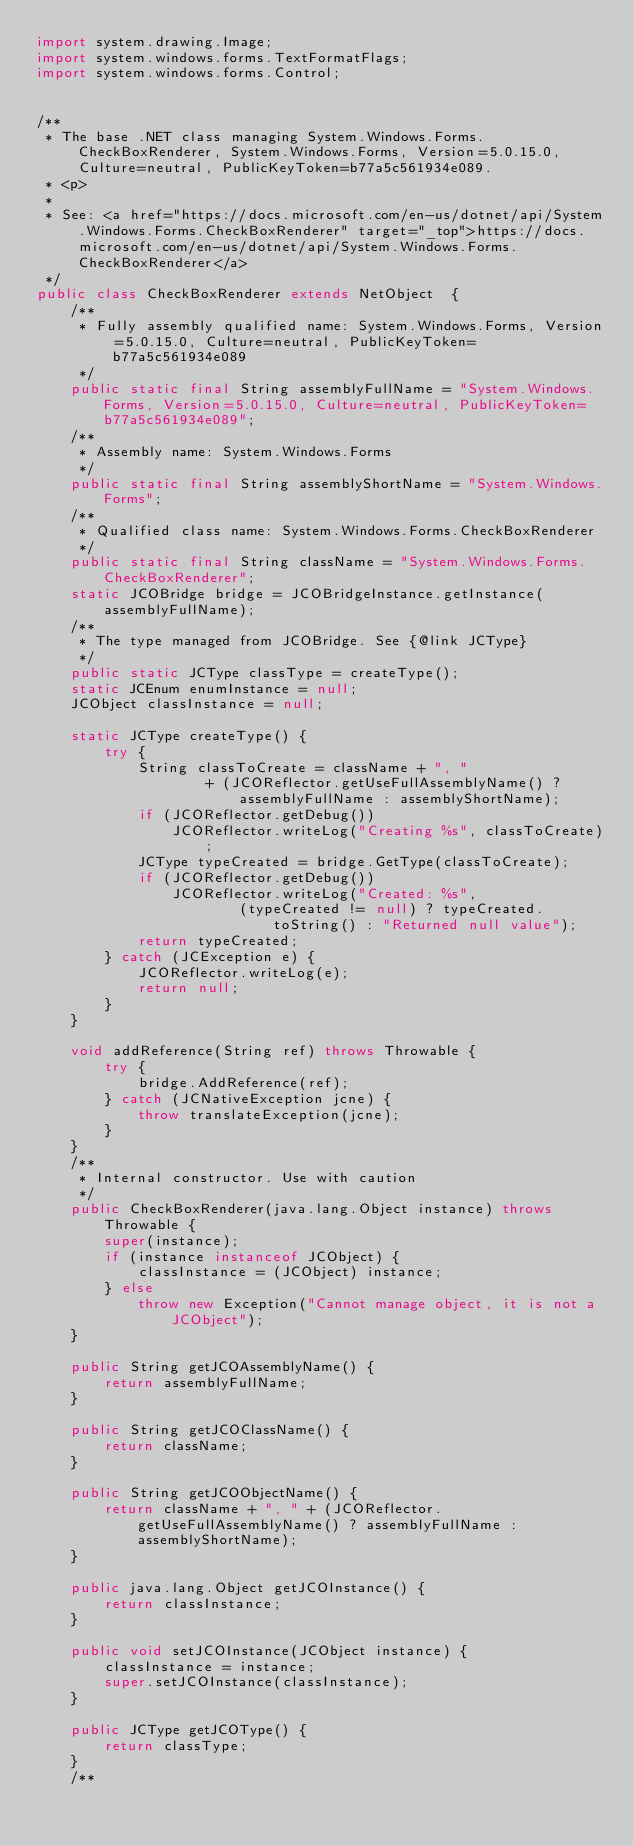<code> <loc_0><loc_0><loc_500><loc_500><_Java_>import system.drawing.Image;
import system.windows.forms.TextFormatFlags;
import system.windows.forms.Control;


/**
 * The base .NET class managing System.Windows.Forms.CheckBoxRenderer, System.Windows.Forms, Version=5.0.15.0, Culture=neutral, PublicKeyToken=b77a5c561934e089.
 * <p>
 * 
 * See: <a href="https://docs.microsoft.com/en-us/dotnet/api/System.Windows.Forms.CheckBoxRenderer" target="_top">https://docs.microsoft.com/en-us/dotnet/api/System.Windows.Forms.CheckBoxRenderer</a>
 */
public class CheckBoxRenderer extends NetObject  {
    /**
     * Fully assembly qualified name: System.Windows.Forms, Version=5.0.15.0, Culture=neutral, PublicKeyToken=b77a5c561934e089
     */
    public static final String assemblyFullName = "System.Windows.Forms, Version=5.0.15.0, Culture=neutral, PublicKeyToken=b77a5c561934e089";
    /**
     * Assembly name: System.Windows.Forms
     */
    public static final String assemblyShortName = "System.Windows.Forms";
    /**
     * Qualified class name: System.Windows.Forms.CheckBoxRenderer
     */
    public static final String className = "System.Windows.Forms.CheckBoxRenderer";
    static JCOBridge bridge = JCOBridgeInstance.getInstance(assemblyFullName);
    /**
     * The type managed from JCOBridge. See {@link JCType}
     */
    public static JCType classType = createType();
    static JCEnum enumInstance = null;
    JCObject classInstance = null;

    static JCType createType() {
        try {
            String classToCreate = className + ", "
                    + (JCOReflector.getUseFullAssemblyName() ? assemblyFullName : assemblyShortName);
            if (JCOReflector.getDebug())
                JCOReflector.writeLog("Creating %s", classToCreate);
            JCType typeCreated = bridge.GetType(classToCreate);
            if (JCOReflector.getDebug())
                JCOReflector.writeLog("Created: %s",
                        (typeCreated != null) ? typeCreated.toString() : "Returned null value");
            return typeCreated;
        } catch (JCException e) {
            JCOReflector.writeLog(e);
            return null;
        }
    }

    void addReference(String ref) throws Throwable {
        try {
            bridge.AddReference(ref);
        } catch (JCNativeException jcne) {
            throw translateException(jcne);
        }
    }
    /**
     * Internal constructor. Use with caution 
     */
    public CheckBoxRenderer(java.lang.Object instance) throws Throwable {
        super(instance);
        if (instance instanceof JCObject) {
            classInstance = (JCObject) instance;
        } else
            throw new Exception("Cannot manage object, it is not a JCObject");
    }

    public String getJCOAssemblyName() {
        return assemblyFullName;
    }

    public String getJCOClassName() {
        return className;
    }

    public String getJCOObjectName() {
        return className + ", " + (JCOReflector.getUseFullAssemblyName() ? assemblyFullName : assemblyShortName);
    }

    public java.lang.Object getJCOInstance() {
        return classInstance;
    }

    public void setJCOInstance(JCObject instance) {
        classInstance = instance;
        super.setJCOInstance(classInstance);
    }

    public JCType getJCOType() {
        return classType;
    }
    /**</code> 